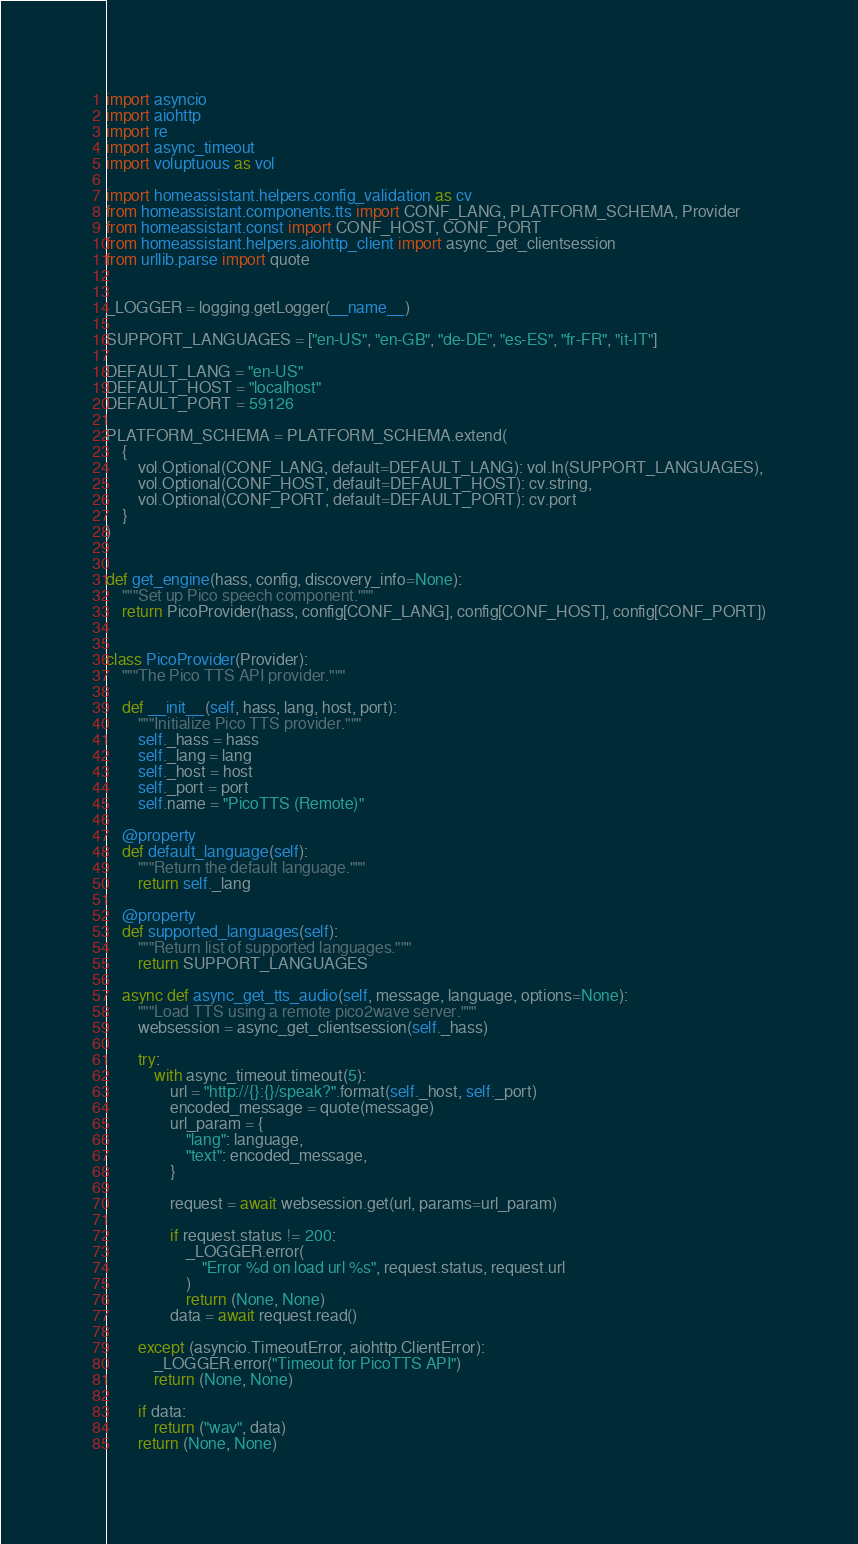Convert code to text. <code><loc_0><loc_0><loc_500><loc_500><_Python_>
import asyncio
import aiohttp
import re
import async_timeout
import voluptuous as vol

import homeassistant.helpers.config_validation as cv
from homeassistant.components.tts import CONF_LANG, PLATFORM_SCHEMA, Provider
from homeassistant.const import CONF_HOST, CONF_PORT
from homeassistant.helpers.aiohttp_client import async_get_clientsession
from urllib.parse import quote


_LOGGER = logging.getLogger(__name__)

SUPPORT_LANGUAGES = ["en-US", "en-GB", "de-DE", "es-ES", "fr-FR", "it-IT"]

DEFAULT_LANG = "en-US"
DEFAULT_HOST = "localhost"
DEFAULT_PORT = 59126

PLATFORM_SCHEMA = PLATFORM_SCHEMA.extend(
    {
        vol.Optional(CONF_LANG, default=DEFAULT_LANG): vol.In(SUPPORT_LANGUAGES),
        vol.Optional(CONF_HOST, default=DEFAULT_HOST): cv.string,
        vol.Optional(CONF_PORT, default=DEFAULT_PORT): cv.port
    }
)


def get_engine(hass, config, discovery_info=None):
    """Set up Pico speech component."""
    return PicoProvider(hass, config[CONF_LANG], config[CONF_HOST], config[CONF_PORT])


class PicoProvider(Provider):
    """The Pico TTS API provider."""

    def __init__(self, hass, lang, host, port):
        """Initialize Pico TTS provider."""
        self._hass = hass
        self._lang = lang
        self._host = host
        self._port = port
        self.name = "PicoTTS (Remote)"

    @property
    def default_language(self):
        """Return the default language."""
        return self._lang

    @property
    def supported_languages(self):
        """Return list of supported languages."""
        return SUPPORT_LANGUAGES

    async def async_get_tts_audio(self, message, language, options=None):
        """Load TTS using a remote pico2wave server."""
        websession = async_get_clientsession(self._hass)

        try:
            with async_timeout.timeout(5):
                url = "http://{}:{}/speak?".format(self._host, self._port)
                encoded_message = quote(message)
                url_param = {
                    "lang": language,
                    "text": encoded_message,
                }

                request = await websession.get(url, params=url_param)

                if request.status != 200:
                    _LOGGER.error(
                        "Error %d on load url %s", request.status, request.url
                    )
                    return (None, None)
                data = await request.read()

        except (asyncio.TimeoutError, aiohttp.ClientError):
            _LOGGER.error("Timeout for PicoTTS API")
            return (None, None)

        if data:
            return ("wav", data)
        return (None, None)
</code> 